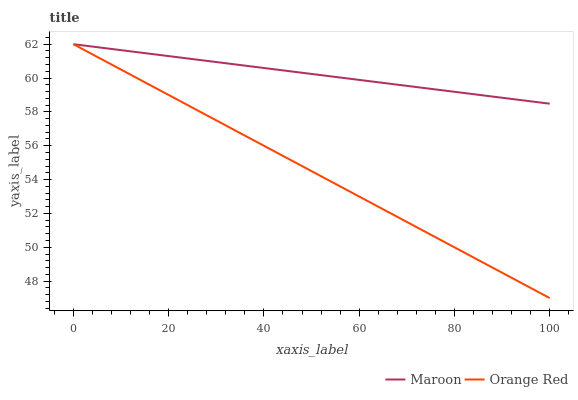Does Orange Red have the minimum area under the curve?
Answer yes or no. Yes. Does Maroon have the maximum area under the curve?
Answer yes or no. Yes. Does Maroon have the minimum area under the curve?
Answer yes or no. No. Is Maroon the smoothest?
Answer yes or no. Yes. Is Orange Red the roughest?
Answer yes or no. Yes. Is Maroon the roughest?
Answer yes or no. No. Does Orange Red have the lowest value?
Answer yes or no. Yes. Does Maroon have the lowest value?
Answer yes or no. No. Does Maroon have the highest value?
Answer yes or no. Yes. Does Maroon intersect Orange Red?
Answer yes or no. Yes. Is Maroon less than Orange Red?
Answer yes or no. No. Is Maroon greater than Orange Red?
Answer yes or no. No. 